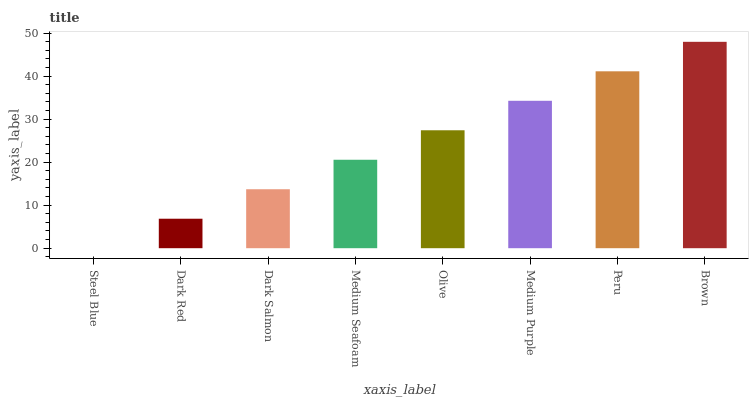Is Steel Blue the minimum?
Answer yes or no. Yes. Is Brown the maximum?
Answer yes or no. Yes. Is Dark Red the minimum?
Answer yes or no. No. Is Dark Red the maximum?
Answer yes or no. No. Is Dark Red greater than Steel Blue?
Answer yes or no. Yes. Is Steel Blue less than Dark Red?
Answer yes or no. Yes. Is Steel Blue greater than Dark Red?
Answer yes or no. No. Is Dark Red less than Steel Blue?
Answer yes or no. No. Is Olive the high median?
Answer yes or no. Yes. Is Medium Seafoam the low median?
Answer yes or no. Yes. Is Medium Purple the high median?
Answer yes or no. No. Is Medium Purple the low median?
Answer yes or no. No. 